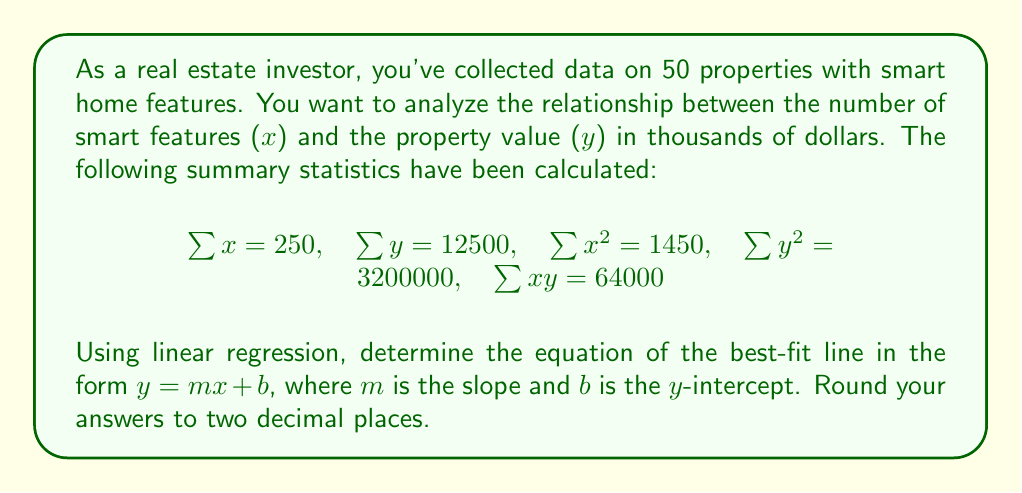Solve this math problem. To find the equation of the best-fit line using linear regression, we need to calculate the slope (m) and y-intercept (b). We'll use the following formulas:

1. Slope (m): 
   $$m = \frac{n\sum xy - \sum x \sum y}{n\sum x^2 - (\sum x)^2}$$

2. Y-intercept (b):
   $$b = \frac{\sum y - m\sum x}{n}$$

Where n is the number of data points (50 in this case).

Step 1: Calculate the slope (m)
$$m = \frac{50(64000) - (250)(12500)}{50(1450) - (250)^2}$$
$$m = \frac{3200000 - 3125000}{72500 - 62500}$$
$$m = \frac{75000}{10000} = 7.5$$

Step 2: Calculate the y-intercept (b)
$$b = \frac{12500 - 7.5(250)}{50}$$
$$b = \frac{12500 - 1875}{50}$$
$$b = \frac{10625}{50} = 212.5$$

Step 3: Form the equation of the best-fit line
y = mx + b
y = 7.5x + 212.5

Rounding to two decimal places:
y = 7.50x + 212.50
Answer: y = 7.50x + 212.50 